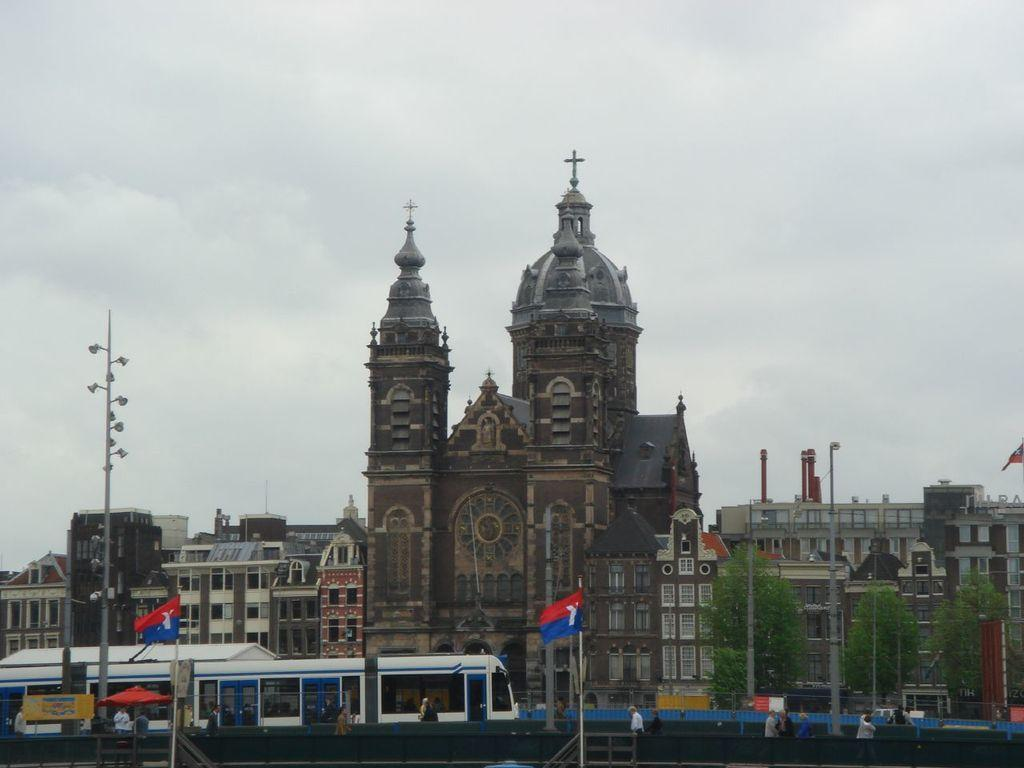What type of structures can be seen in the image? There are buildings in the image. What type of vegetation is on the right side of the image? There are green trees on the right side of the image. What is visible at the top of the image? The sky is visible at the top of the image. What wilderness theory is being discussed in the image? There is no discussion or theory present in the image; it features buildings, green trees, and the sky. Who needs to approve the image? The image does not require approval, as it is a static representation of a scene. 